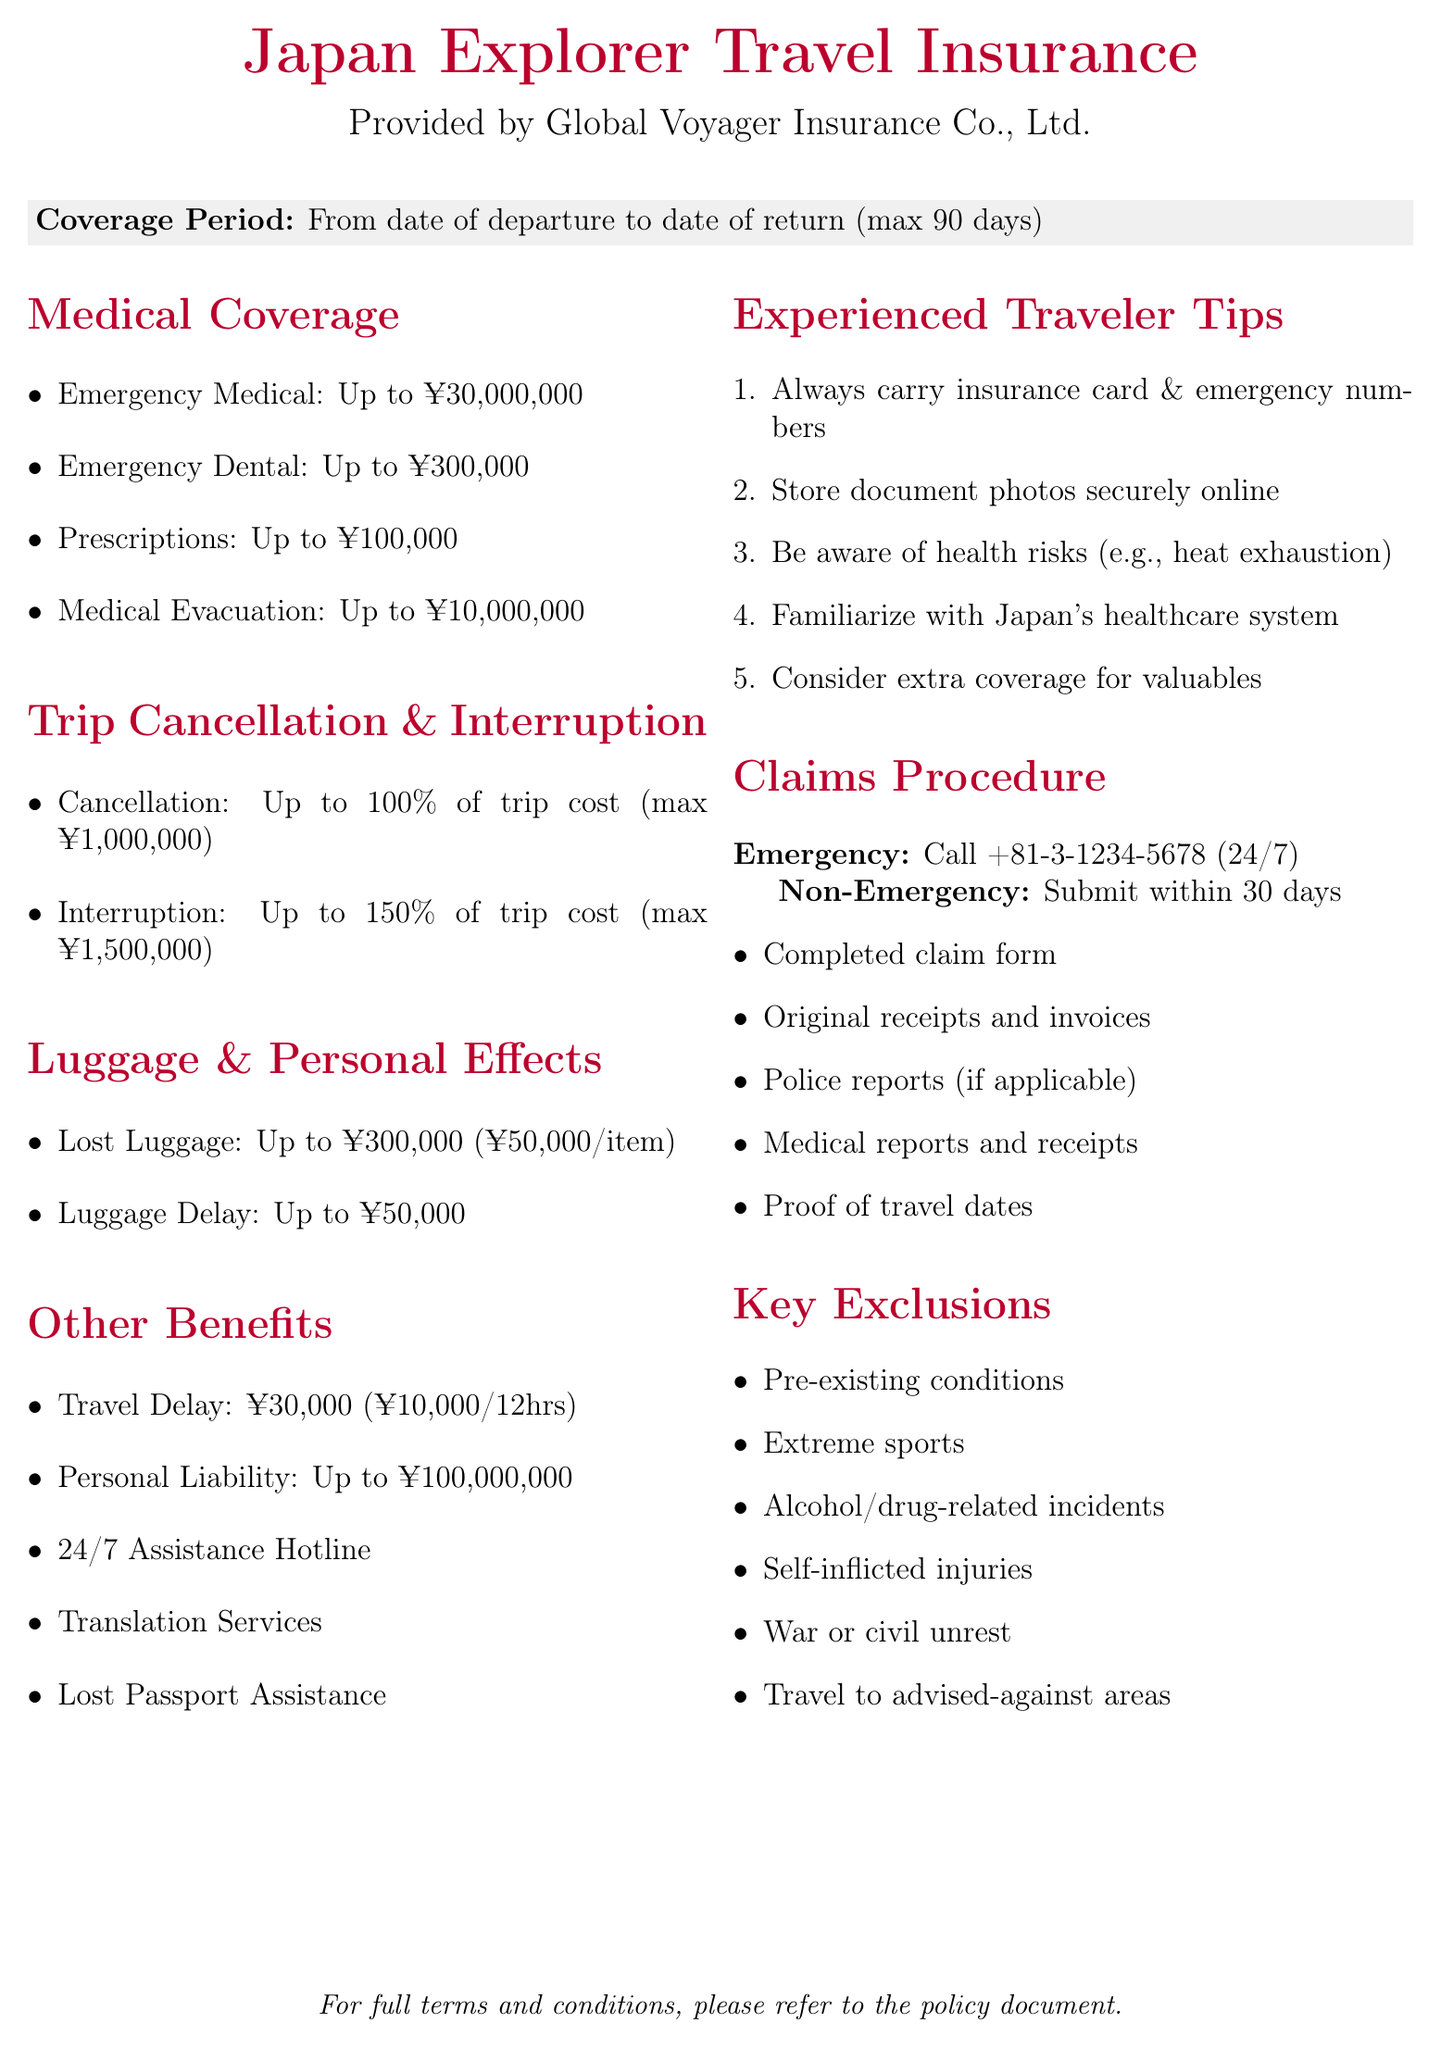What is the name of the travel insurance policy? The name of the travel insurance policy is mentioned at the beginning of the document.
Answer: Japan Explorer Travel Insurance Who is the insurance provider? The insurance provider is stated in the document.
Answer: Global Voyager Insurance Co., Ltd What is the limit for emergency medical expenses? The limit for emergency medical expenses is specified in the medical coverage section.
Answer: ¥30,000,000 What are the covered reasons for trip cancellation? The document lists the covered reasons for trip cancellation in the relevant section.
Answer: Unexpected illness or injury, natural disasters, terrorism, job loss, legal obligation What is the coverage limit for lost luggage? The document provides the coverage limit for lost luggage in the luggage and personal effects section.
Answer: ¥300,000 (¥50,000 per item) What is required for a non-emergency claim submission? The claims procedure includes a list of required documents for non-emergency claims.
Answer: Completed claim form, original receipts, police reports, medical reports, proof of travel dates What type of coverage is provided for luggage delay? The specific type of coverage for luggage delay can be found in the luggage and personal effects section.
Answer: Provides reimbursement for essential items What is the maximum duration of coverage? The coverage period is described in the document stating the maximum duration.
Answer: Maximum 90 days What should be done in case of a medical emergency? The claims procedure outlines what to do in case of a medical emergency.
Answer: Call our 24/7 hotline: +81-3-1234-5678 